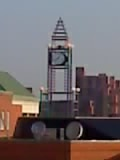Describe the objects in this image and their specific colors. I can see a clock in darkgray, gray, and black tones in this image. 